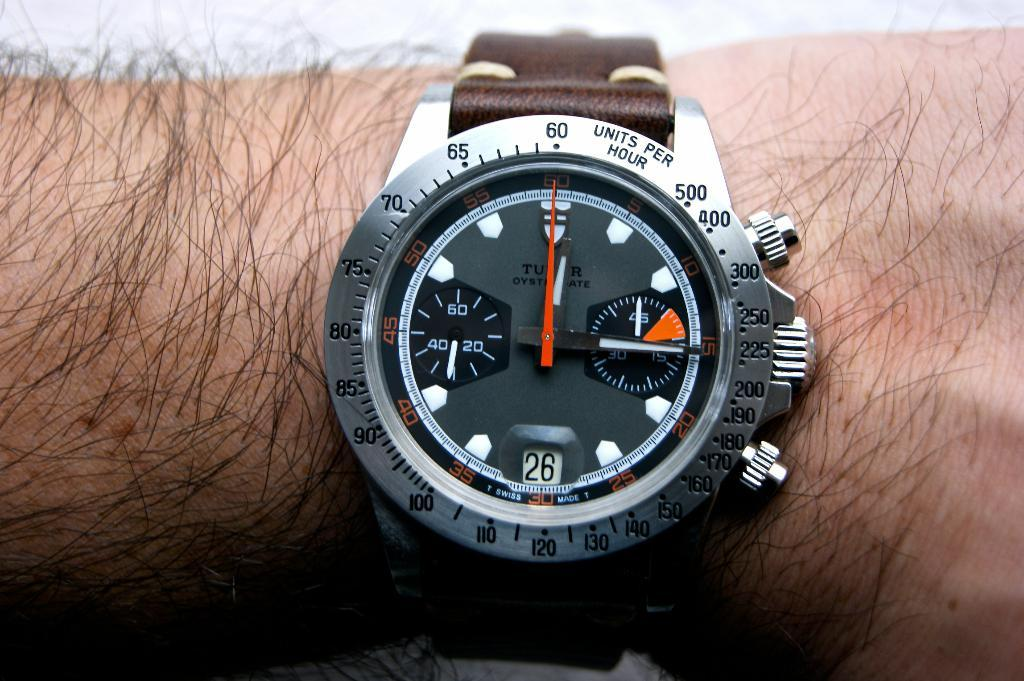<image>
Give a short and clear explanation of the subsequent image. The ring around a watch face says "units per hour". 